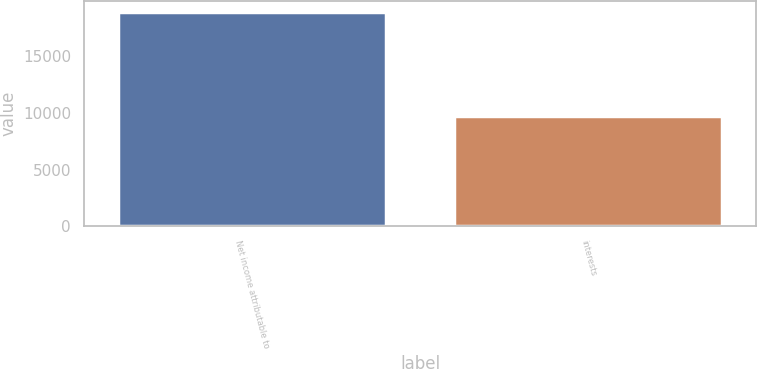Convert chart to OTSL. <chart><loc_0><loc_0><loc_500><loc_500><bar_chart><fcel>Net income attributable to<fcel>interests<nl><fcel>18918<fcel>9717<nl></chart> 